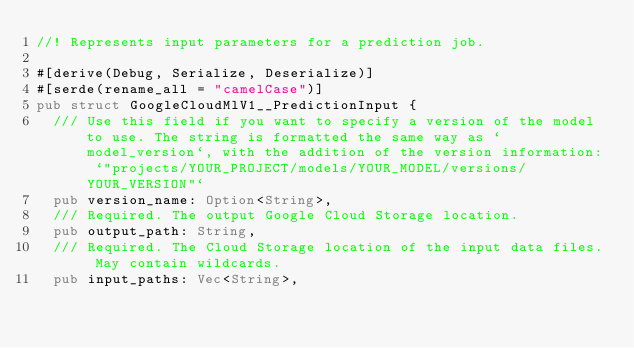Convert code to text. <code><loc_0><loc_0><loc_500><loc_500><_Rust_>//! Represents input parameters for a prediction job.

#[derive(Debug, Serialize, Deserialize)]
#[serde(rename_all = "camelCase")]
pub struct GoogleCloudMlV1__PredictionInput {
	/// Use this field if you want to specify a version of the model to use. The string is formatted the same way as `model_version`, with the addition of the version information: `"projects/YOUR_PROJECT/models/YOUR_MODEL/versions/YOUR_VERSION"`
	pub version_name: Option<String>,
	/// Required. The output Google Cloud Storage location.
	pub output_path: String,
	/// Required. The Cloud Storage location of the input data files. May contain wildcards.
	pub input_paths: Vec<String>,</code> 